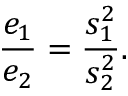<formula> <loc_0><loc_0><loc_500><loc_500>{ \frac { e _ { 1 } } { e _ { 2 } } } = { \frac { s _ { 1 } ^ { 2 } } { s _ { 2 } ^ { 2 } } } .</formula> 